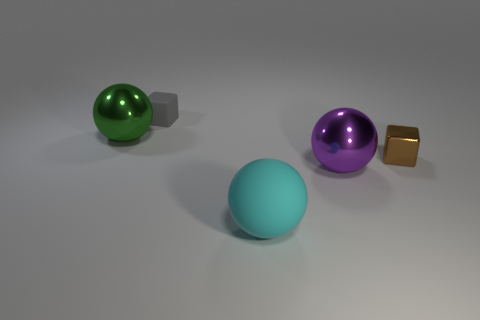Add 1 tiny matte things. How many objects exist? 6 Subtract all blocks. How many objects are left? 3 Subtract 1 green spheres. How many objects are left? 4 Subtract all brown metallic objects. Subtract all big gray cylinders. How many objects are left? 4 Add 4 tiny gray blocks. How many tiny gray blocks are left? 5 Add 3 green metal spheres. How many green metal spheres exist? 4 